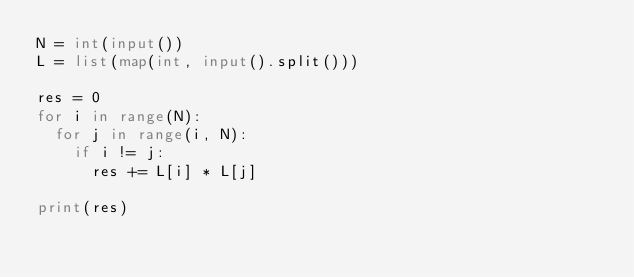<code> <loc_0><loc_0><loc_500><loc_500><_Python_>N = int(input())
L = list(map(int, input().split()))

res = 0
for i in range(N):
  for j in range(i, N):
    if i != j:
    	res += L[i] * L[j]
        
print(res)</code> 